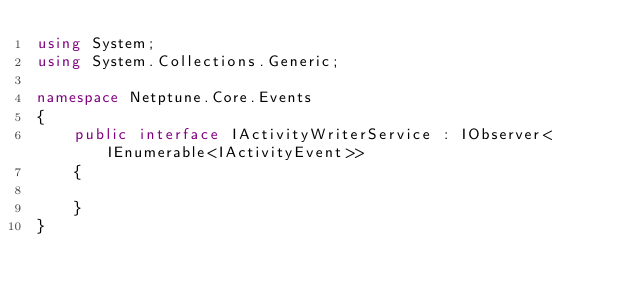Convert code to text. <code><loc_0><loc_0><loc_500><loc_500><_C#_>using System;
using System.Collections.Generic;

namespace Netptune.Core.Events
{
    public interface IActivityWriterService : IObserver<IEnumerable<IActivityEvent>>
    {

    }
}
</code> 